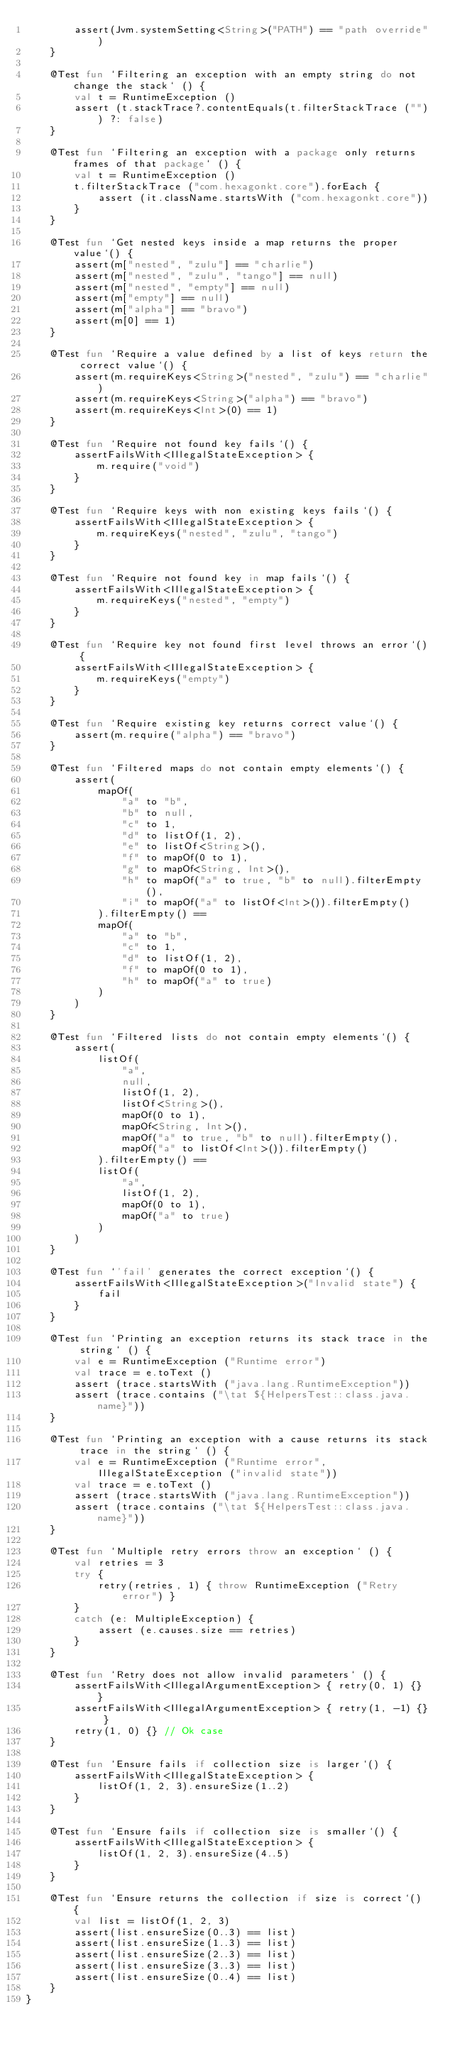Convert code to text. <code><loc_0><loc_0><loc_500><loc_500><_Kotlin_>        assert(Jvm.systemSetting<String>("PATH") == "path override")
    }

    @Test fun `Filtering an exception with an empty string do not change the stack` () {
        val t = RuntimeException ()
        assert (t.stackTrace?.contentEquals(t.filterStackTrace ("")) ?: false)
    }

    @Test fun `Filtering an exception with a package only returns frames of that package` () {
        val t = RuntimeException ()
        t.filterStackTrace ("com.hexagonkt.core").forEach {
            assert (it.className.startsWith ("com.hexagonkt.core"))
        }
    }

    @Test fun `Get nested keys inside a map returns the proper value`() {
        assert(m["nested", "zulu"] == "charlie")
        assert(m["nested", "zulu", "tango"] == null)
        assert(m["nested", "empty"] == null)
        assert(m["empty"] == null)
        assert(m["alpha"] == "bravo")
        assert(m[0] == 1)
    }

    @Test fun `Require a value defined by a list of keys return the correct value`() {
        assert(m.requireKeys<String>("nested", "zulu") == "charlie")
        assert(m.requireKeys<String>("alpha") == "bravo")
        assert(m.requireKeys<Int>(0) == 1)
    }

    @Test fun `Require not found key fails`() {
        assertFailsWith<IllegalStateException> {
            m.require("void")
        }
    }

    @Test fun `Require keys with non existing keys fails`() {
        assertFailsWith<IllegalStateException> {
            m.requireKeys("nested", "zulu", "tango")
        }
    }

    @Test fun `Require not found key in map fails`() {
        assertFailsWith<IllegalStateException> {
            m.requireKeys("nested", "empty")
        }
    }

    @Test fun `Require key not found first level throws an error`() {
        assertFailsWith<IllegalStateException> {
            m.requireKeys("empty")
        }
    }

    @Test fun `Require existing key returns correct value`() {
        assert(m.require("alpha") == "bravo")
    }

    @Test fun `Filtered maps do not contain empty elements`() {
        assert(
            mapOf(
                "a" to "b",
                "b" to null,
                "c" to 1,
                "d" to listOf(1, 2),
                "e" to listOf<String>(),
                "f" to mapOf(0 to 1),
                "g" to mapOf<String, Int>(),
                "h" to mapOf("a" to true, "b" to null).filterEmpty(),
                "i" to mapOf("a" to listOf<Int>()).filterEmpty()
            ).filterEmpty() ==
            mapOf(
                "a" to "b",
                "c" to 1,
                "d" to listOf(1, 2),
                "f" to mapOf(0 to 1),
                "h" to mapOf("a" to true)
            )
        )
    }

    @Test fun `Filtered lists do not contain empty elements`() {
        assert(
            listOf(
                "a",
                null,
                listOf(1, 2),
                listOf<String>(),
                mapOf(0 to 1),
                mapOf<String, Int>(),
                mapOf("a" to true, "b" to null).filterEmpty(),
                mapOf("a" to listOf<Int>()).filterEmpty()
            ).filterEmpty() ==
            listOf(
                "a",
                listOf(1, 2),
                mapOf(0 to 1),
                mapOf("a" to true)
            )
        )
    }

    @Test fun `'fail' generates the correct exception`() {
        assertFailsWith<IllegalStateException>("Invalid state") {
            fail
        }
    }

    @Test fun `Printing an exception returns its stack trace in the string` () {
        val e = RuntimeException ("Runtime error")
        val trace = e.toText ()
        assert (trace.startsWith ("java.lang.RuntimeException"))
        assert (trace.contains ("\tat ${HelpersTest::class.java.name}"))
    }

    @Test fun `Printing an exception with a cause returns its stack trace in the string` () {
        val e = RuntimeException ("Runtime error", IllegalStateException ("invalid state"))
        val trace = e.toText ()
        assert (trace.startsWith ("java.lang.RuntimeException"))
        assert (trace.contains ("\tat ${HelpersTest::class.java.name}"))
    }

    @Test fun `Multiple retry errors throw an exception` () {
        val retries = 3
        try {
            retry(retries, 1) { throw RuntimeException ("Retry error") }
        }
        catch (e: MultipleException) {
            assert (e.causes.size == retries)
        }
    }

    @Test fun `Retry does not allow invalid parameters` () {
        assertFailsWith<IllegalArgumentException> { retry(0, 1) {} }
        assertFailsWith<IllegalArgumentException> { retry(1, -1) {} }
        retry(1, 0) {} // Ok case
    }

    @Test fun `Ensure fails if collection size is larger`() {
        assertFailsWith<IllegalStateException> {
            listOf(1, 2, 3).ensureSize(1..2)
        }
    }

    @Test fun `Ensure fails if collection size is smaller`() {
        assertFailsWith<IllegalStateException> {
            listOf(1, 2, 3).ensureSize(4..5)
        }
    }

    @Test fun `Ensure returns the collection if size is correct`() {
        val list = listOf(1, 2, 3)
        assert(list.ensureSize(0..3) == list)
        assert(list.ensureSize(1..3) == list)
        assert(list.ensureSize(2..3) == list)
        assert(list.ensureSize(3..3) == list)
        assert(list.ensureSize(0..4) == list)
    }
}
</code> 